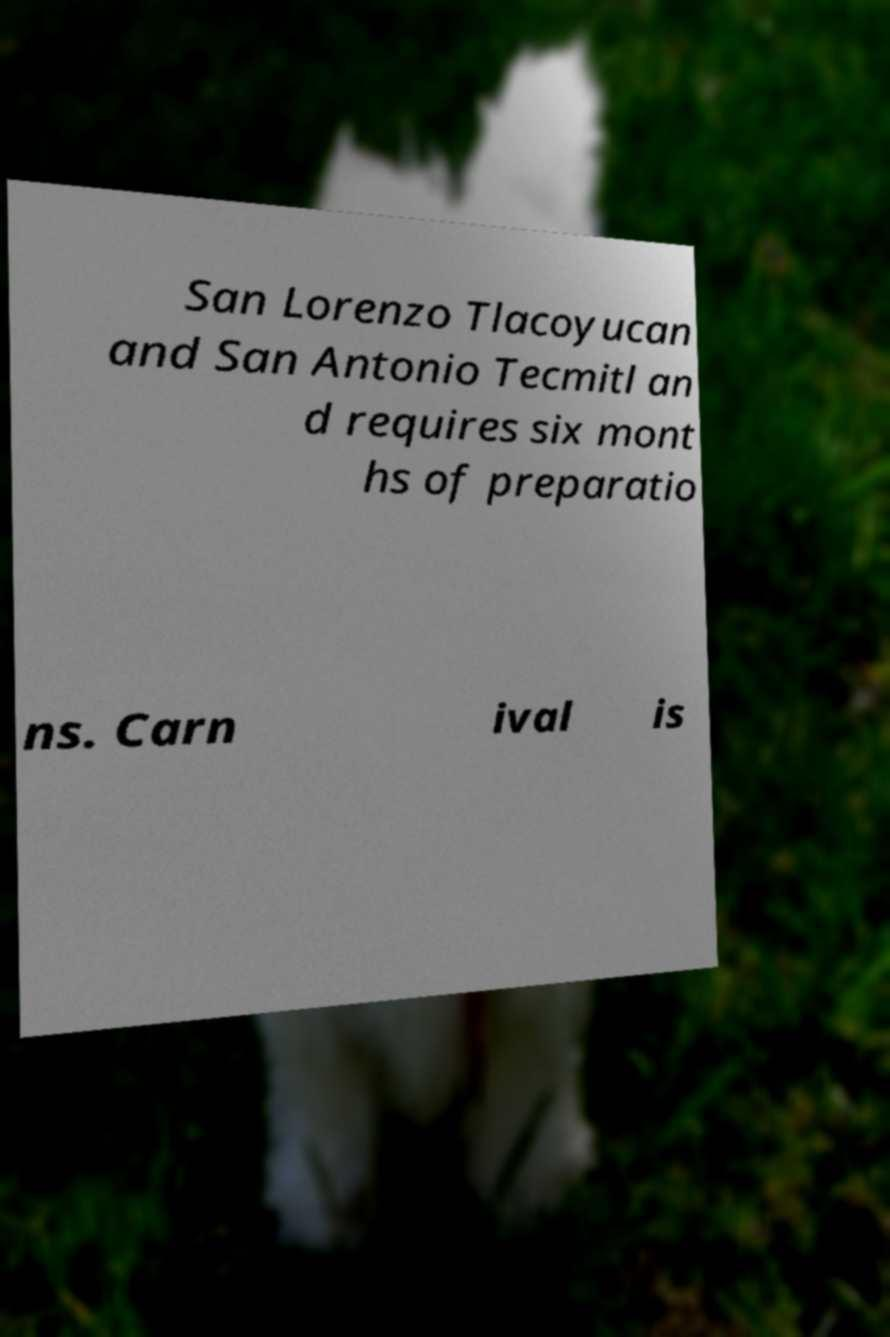Could you extract and type out the text from this image? San Lorenzo Tlacoyucan and San Antonio Tecmitl an d requires six mont hs of preparatio ns. Carn ival is 